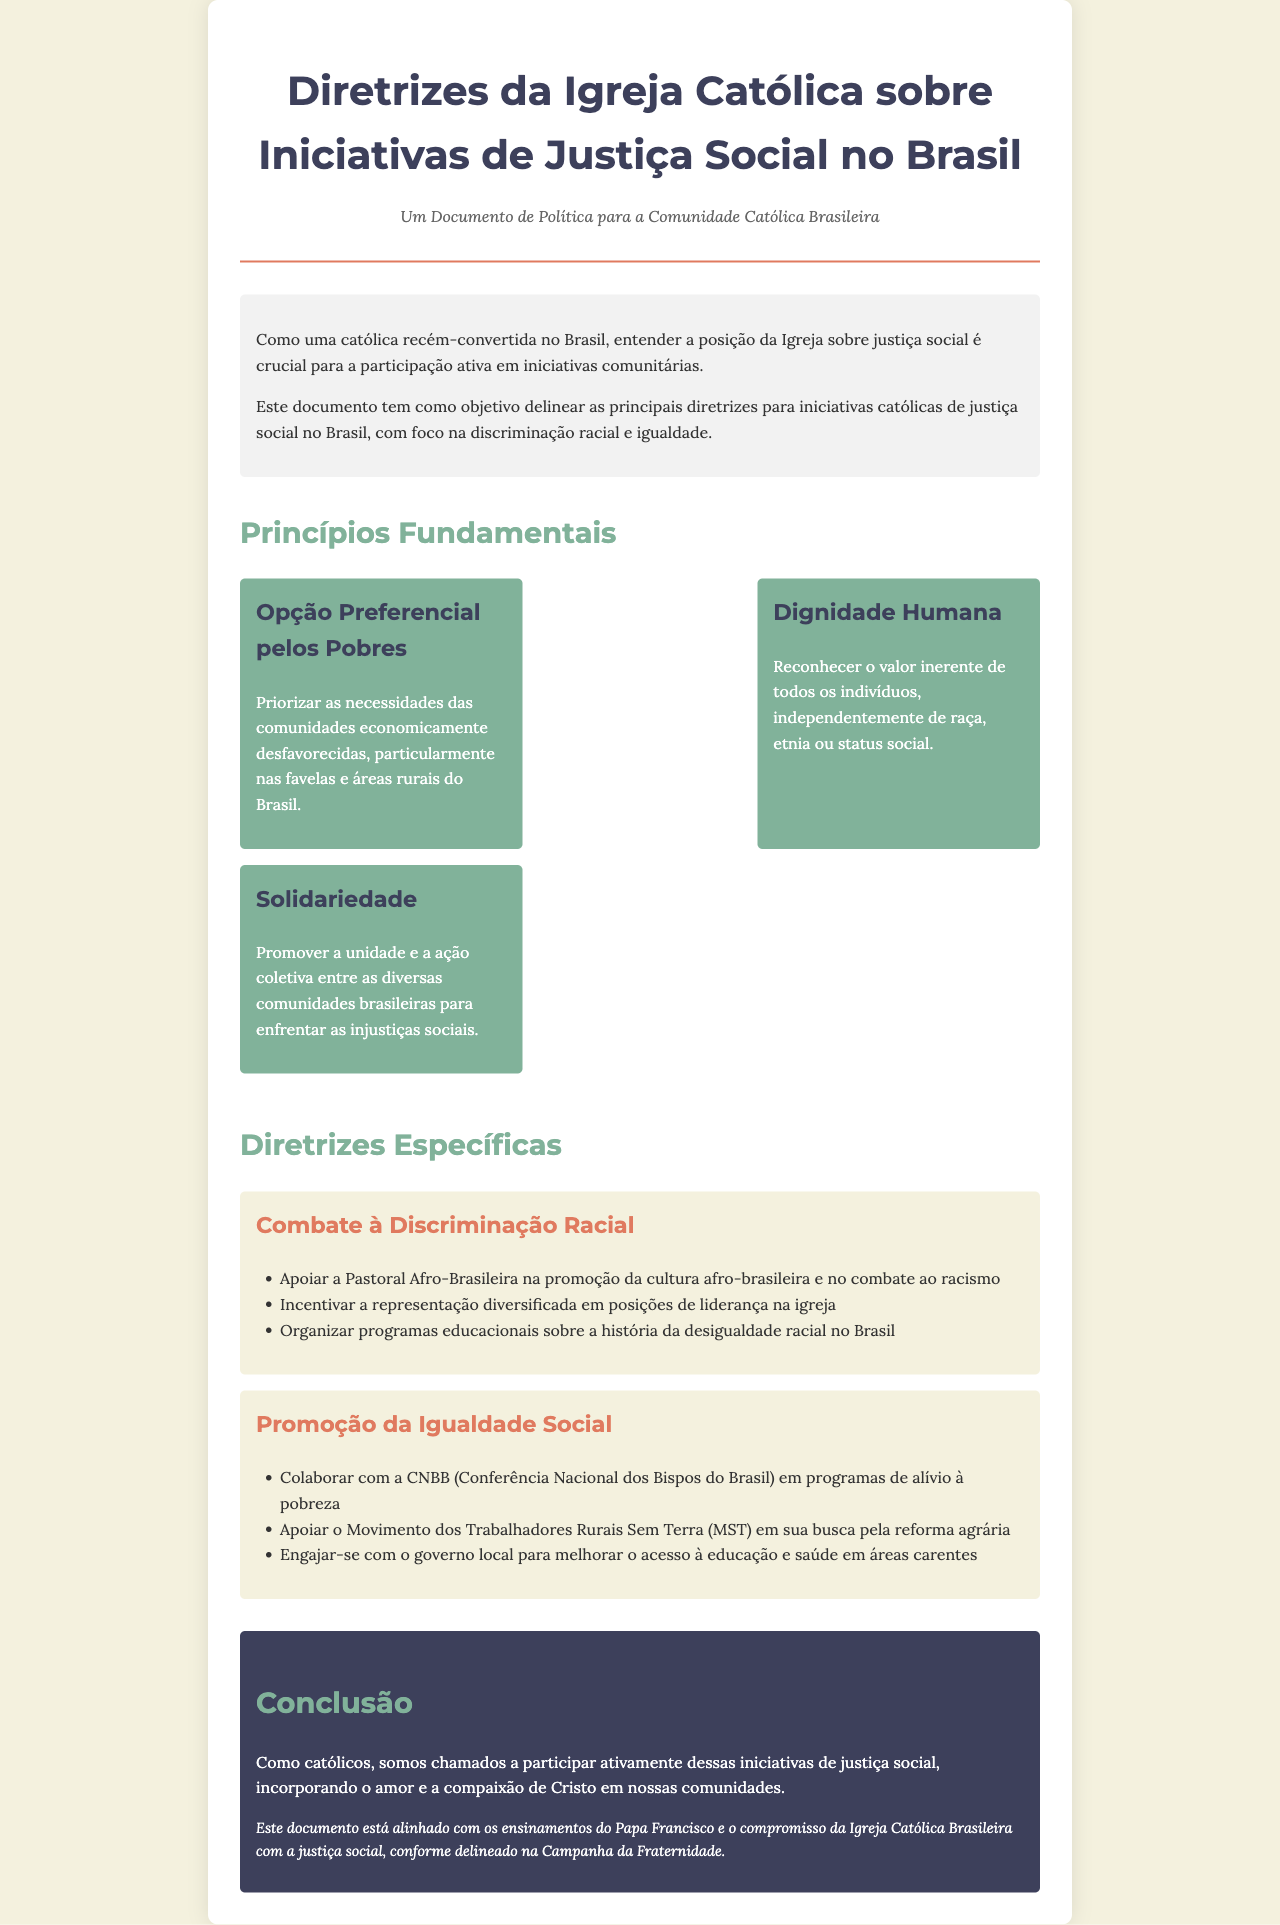what is the title of the document? The title is presented at the top of the rendered document in a prominent font.
Answer: Diretrizes da Igreja Católica sobre Iniciativas de Justiça Social no Brasil what is the subtitle of the document? The subtitle provides a brief description of the document's purpose.
Answer: Um Documento de Política para a Comunidade Católica Brasileira what is the first fundamental principle mentioned? The first principle is highlighted in a separate section, focusing on its importance.
Answer: Opção Preferencial pelos Pobres how many key principles are listed? The number of principles is determined by counting the entries under key principles.
Answer: Three which organization is supported for promoting the culture afro-brasileira? This organization is mentioned in the context of combating racial discrimination.
Answer: Pastoral Afro-Brasileira what is one of the specific guidelines for promoting social equality? The guidelines include specific initiatives aimed at achieving social equality.
Answer: Colaborar com a CNBB em programas de alívio à pobreza who is aligned with the teachings cited in the conclusion? The conclusion references a prominent figure known for their teachings on social justice.
Answer: Papa Francisco what is the main call to action for Catholics according to the conclusion? The conclusion summarizes the expected action for the Catholic community.
Answer: Participar ativamente dessas iniciativas de justiça social 